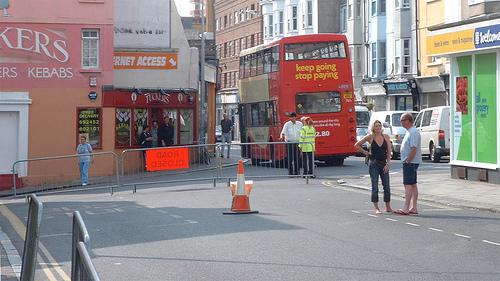Is there a high fence in front of the store?
Give a very brief answer. No. Which building would you enter to buy some lunch?
Be succinct. One on far left. Is the bus moving toward you or away from you?
Quick response, please. Away. Why are there orange cones in the street?
Write a very short answer. Road closed. How many traffic cones do you see?
Short answer required. 1. Is this in an Asian country?
Answer briefly. No. 